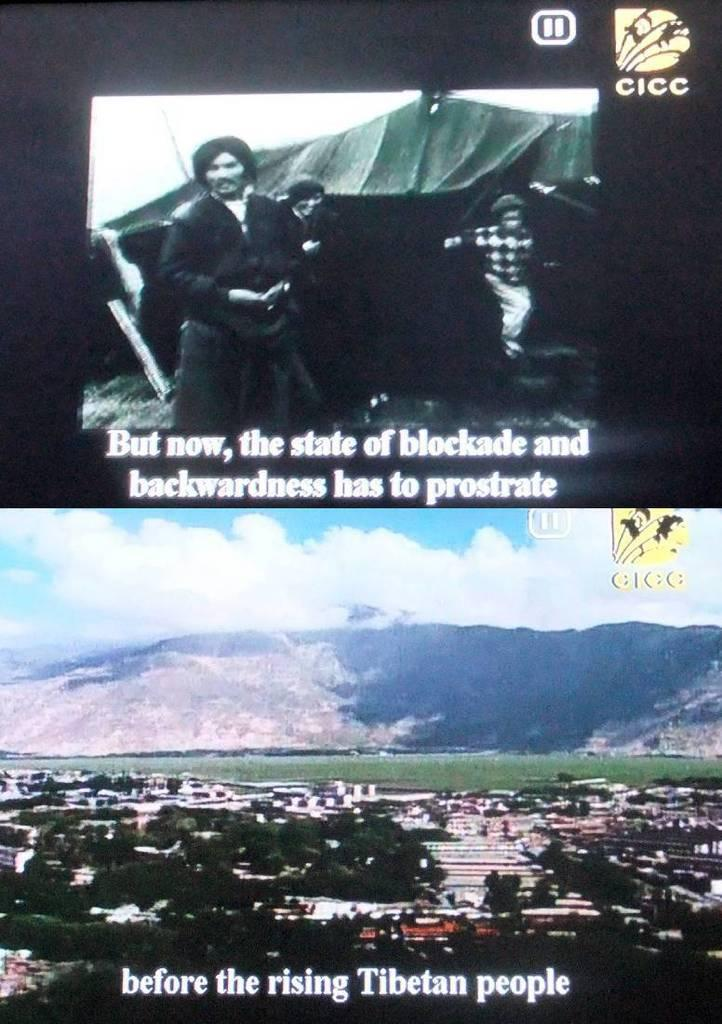<image>
Write a terse but informative summary of the picture. Two screen shots out the state of blockade before the rising of the Tibetan people. 